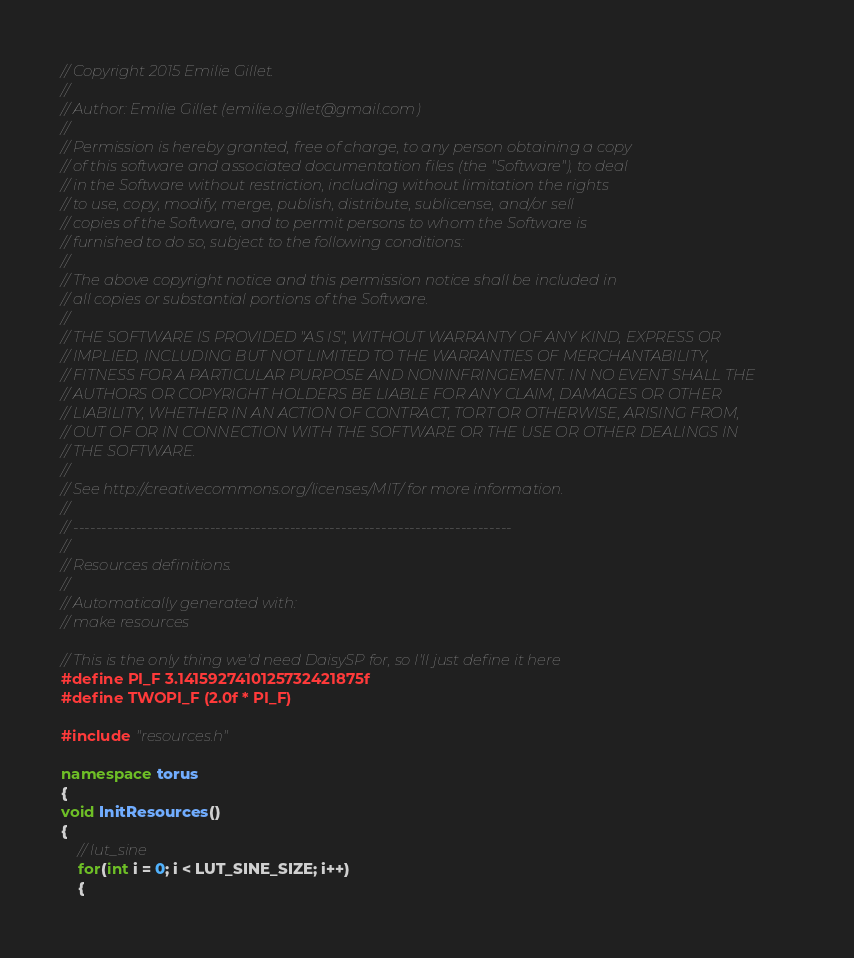Convert code to text. <code><loc_0><loc_0><loc_500><loc_500><_C++_>// Copyright 2015 Emilie Gillet.
//
// Author: Emilie Gillet (emilie.o.gillet@gmail.com)
//
// Permission is hereby granted, free of charge, to any person obtaining a copy
// of this software and associated documentation files (the "Software"), to deal
// in the Software without restriction, including without limitation the rights
// to use, copy, modify, merge, publish, distribute, sublicense, and/or sell
// copies of the Software, and to permit persons to whom the Software is
// furnished to do so, subject to the following conditions:
//
// The above copyright notice and this permission notice shall be included in
// all copies or substantial portions of the Software.
//
// THE SOFTWARE IS PROVIDED "AS IS", WITHOUT WARRANTY OF ANY KIND, EXPRESS OR
// IMPLIED, INCLUDING BUT NOT LIMITED TO THE WARRANTIES OF MERCHANTABILITY,
// FITNESS FOR A PARTICULAR PURPOSE AND NONINFRINGEMENT. IN NO EVENT SHALL THE
// AUTHORS OR COPYRIGHT HOLDERS BE LIABLE FOR ANY CLAIM, DAMAGES OR OTHER
// LIABILITY, WHETHER IN AN ACTION OF CONTRACT, TORT OR OTHERWISE, ARISING FROM,
// OUT OF OR IN CONNECTION WITH THE SOFTWARE OR THE USE OR OTHER DEALINGS IN
// THE SOFTWARE.
//
// See http://creativecommons.org/licenses/MIT/ for more information.
//
// -----------------------------------------------------------------------------
//
// Resources definitions.
//
// Automatically generated with:
// make resources

// This is the only thing we'd need DaisySP for, so I'll just define it here
#define PI_F 3.1415927410125732421875f
#define TWOPI_F (2.0f * PI_F)

#include "resources.h"

namespace torus
{
void InitResources()
{
    // lut_sine
    for(int i = 0; i < LUT_SINE_SIZE; i++)
    {</code> 